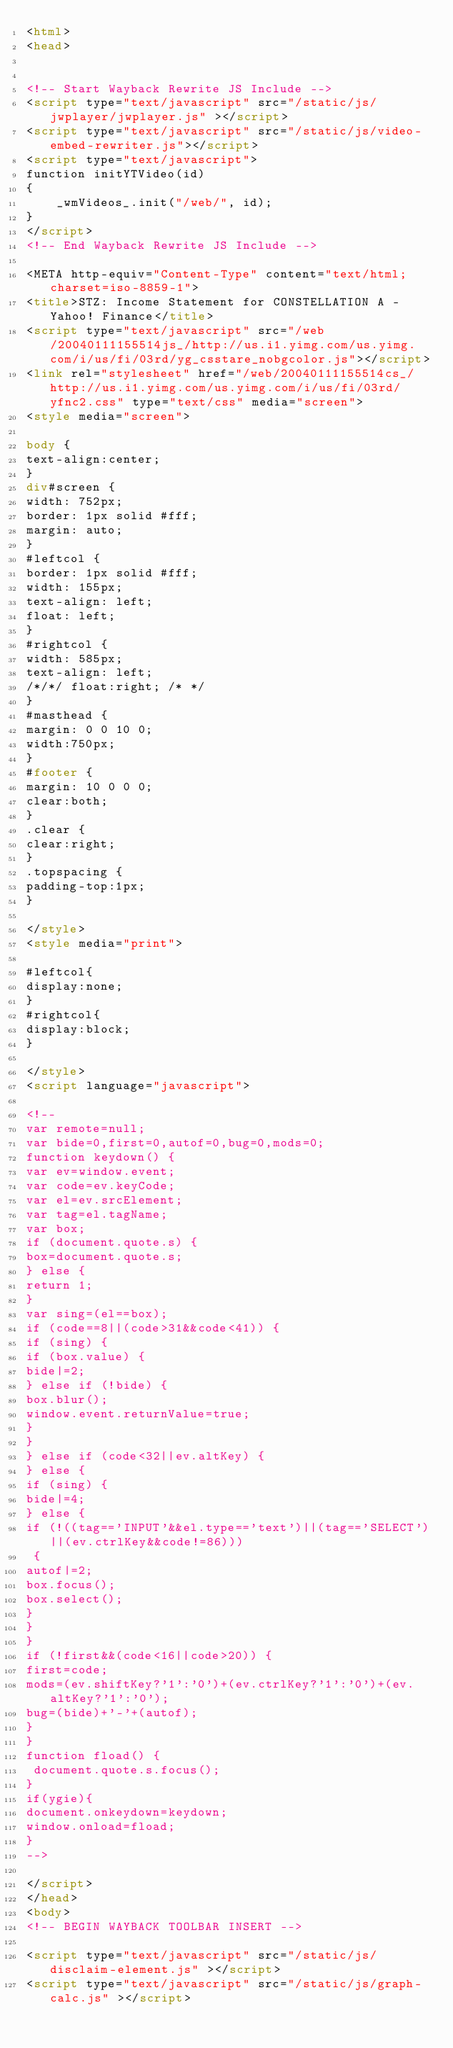<code> <loc_0><loc_0><loc_500><loc_500><_HTML_><html>
<head>


<!-- Start Wayback Rewrite JS Include -->
<script type="text/javascript" src="/static/js/jwplayer/jwplayer.js" ></script>
<script type="text/javascript" src="/static/js/video-embed-rewriter.js"></script>
<script type="text/javascript">
function initYTVideo(id)
{
	_wmVideos_.init("/web/", id);
}
</script>
<!-- End Wayback Rewrite JS Include -->

<META http-equiv="Content-Type" content="text/html; charset=iso-8859-1">
<title>STZ: Income Statement for CONSTELLATION A - Yahoo! Finance</title>
<script type="text/javascript" src="/web/20040111155514js_/http://us.i1.yimg.com/us.yimg.com/i/us/fi/03rd/yg_csstare_nobgcolor.js"></script>
<link rel="stylesheet" href="/web/20040111155514cs_/http://us.i1.yimg.com/us.yimg.com/i/us/fi/03rd/yfnc2.css" type="text/css" media="screen">
<style media="screen">

body {
text-align:center;
}
div#screen {
width: 752px;
border: 1px solid #fff;
margin: auto;
}
#leftcol {
border: 1px solid #fff;
width: 155px;
text-align: left;
float: left;
}
#rightcol {
width: 585px;
text-align: left;
/*/*/ float:right; /* */
}
#masthead {
margin: 0 0 10 0;
width:750px;
}
#footer {
margin: 10 0 0 0;
clear:both;
}
.clear {
clear:right;
}
.topspacing {
padding-top:1px;
}

</style>
<style media="print">

#leftcol{
display:none;
}
#rightcol{
display:block;
}

</style>
<script language="javascript">

<!--
var remote=null;
var bide=0,first=0,autof=0,bug=0,mods=0;
function keydown() {
var ev=window.event;
var code=ev.keyCode;
var el=ev.srcElement;
var tag=el.tagName;
var box;
if (document.quote.s) {
box=document.quote.s;
} else {
return 1;
}
var sing=(el==box);
if (code==8||(code>31&&code<41)) {
if (sing) {
if (box.value) {
bide|=2;
} else if (!bide) {
box.blur();
window.event.returnValue=true;
}
}
} else if (code<32||ev.altKey) {
} else {
if (sing) {
bide|=4;
} else {
if (!((tag=='INPUT'&&el.type=='text')||(tag=='SELECT')||(ev.ctrlKey&&code!=86)))
 {
autof|=2;
box.focus();
box.select();
}
}
}
if (!first&&(code<16||code>20)) {
first=code;
mods=(ev.shiftKey?'1':'0')+(ev.ctrlKey?'1':'0')+(ev.altKey?'1':'0');
bug=(bide)+'-'+(autof);
}
}
function fload() {
 document.quote.s.focus();
}
if(ygie){
document.onkeydown=keydown;
window.onload=fload;
}
-->

</script>
</head>
<body>
<!-- BEGIN WAYBACK TOOLBAR INSERT -->

<script type="text/javascript" src="/static/js/disclaim-element.js" ></script>
<script type="text/javascript" src="/static/js/graph-calc.js" ></script></code> 